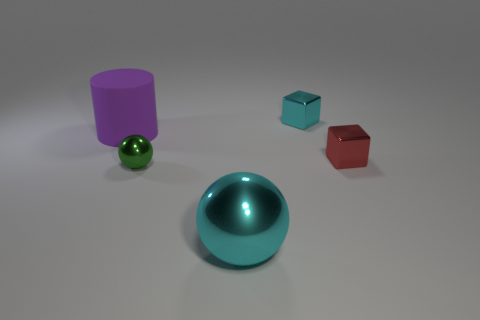Add 2 big brown rubber things. How many objects exist? 7 Subtract all cubes. How many objects are left? 3 Subtract all red things. Subtract all cyan blocks. How many objects are left? 3 Add 1 tiny red metallic cubes. How many tiny red metallic cubes are left? 2 Add 4 red things. How many red things exist? 5 Subtract 1 green spheres. How many objects are left? 4 